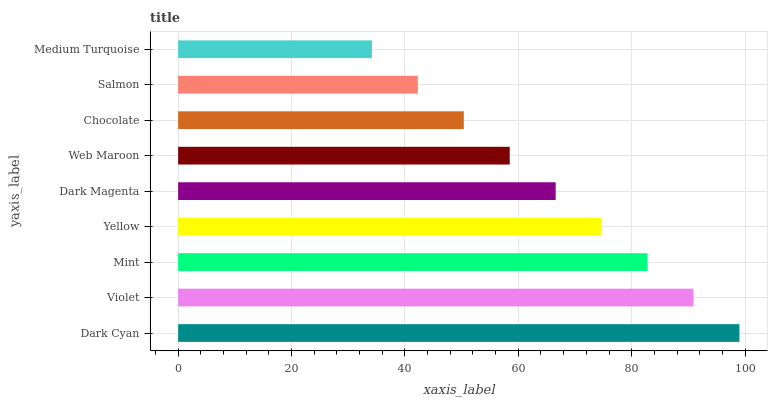Is Medium Turquoise the minimum?
Answer yes or no. Yes. Is Dark Cyan the maximum?
Answer yes or no. Yes. Is Violet the minimum?
Answer yes or no. No. Is Violet the maximum?
Answer yes or no. No. Is Dark Cyan greater than Violet?
Answer yes or no. Yes. Is Violet less than Dark Cyan?
Answer yes or no. Yes. Is Violet greater than Dark Cyan?
Answer yes or no. No. Is Dark Cyan less than Violet?
Answer yes or no. No. Is Dark Magenta the high median?
Answer yes or no. Yes. Is Dark Magenta the low median?
Answer yes or no. Yes. Is Yellow the high median?
Answer yes or no. No. Is Dark Cyan the low median?
Answer yes or no. No. 